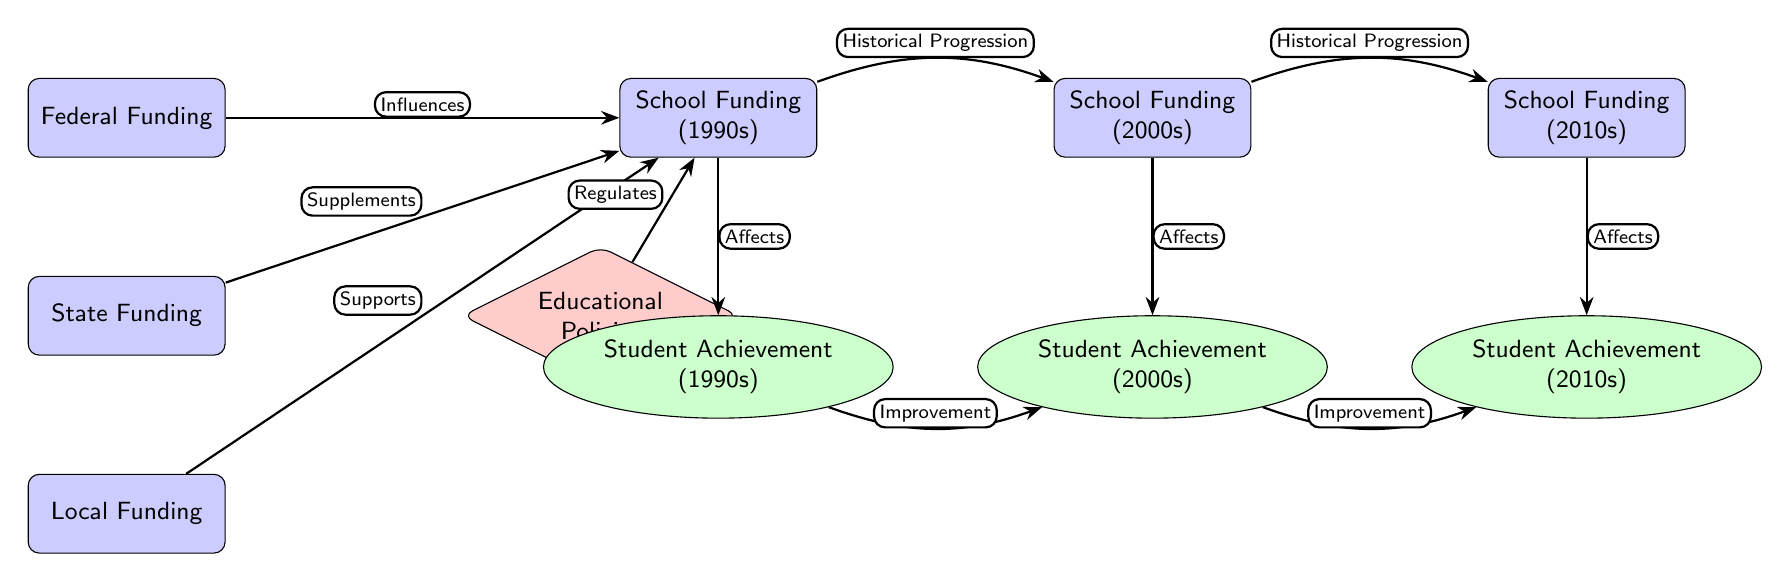What are the three sources of school funding indicated in the diagram? The diagram lists three nodes under school funding sources: Federal Funding, State Funding, and Local Funding.
Answer: Federal Funding, State Funding, Local Funding What are the years associated with the student achievement levels in the diagram? The diagram shows three distinct periods for student achievement: 1990s, 2000s, and 2010s. Each achievement node is directly below its corresponding funding node from the same period.
Answer: 1990s, 2000s, 2010s How many types of funding are represented in the diagram? There are three types of funding nodes in the diagram: Federal Funding, State Funding, and Local Funding.
Answer: Three What does the arrow labeled “Regulates” connect? The "Regulates" arrow connects the educational policies node to the school funding node from the 1990s, indicating that educational policies play a role in regulating funding during that time period.
Answer: Educational Policies to School Funding (1990s) What is the relationship between school funding in the 1990s and student achievement in the 1990s? The arrow labeled "Affects" connects the school funding node from the 1990s to the student achievement node from the same period, showing that school funding has a direct influence on achievement outcomes during that time.
Answer: Affects What is the significance of the arrows labeled "Historical Progression"? The arrows marked "Historical Progression" indicate the flow from school funding in the 1990s to the 2000s and then to the 2010s, illustrating how past funding influences current funding levels over time.
Answer: Indicates funding influence over time How do educational policies affect school funding in the diagram? The arrow connecting educational policies to school funding indicates that educational policies directly regulate the amount and distribution of school funding, particularly in the 1990s, as shown in the diagram.
Answer: Regulates Which node reflects student achievement in the 2010s? The node labeled "Student Achievement (2010s)" represents the level of student achievement during that decade and is visually placed below the "School Funding (2010s)" node.
Answer: Student Achievement (2010s) 